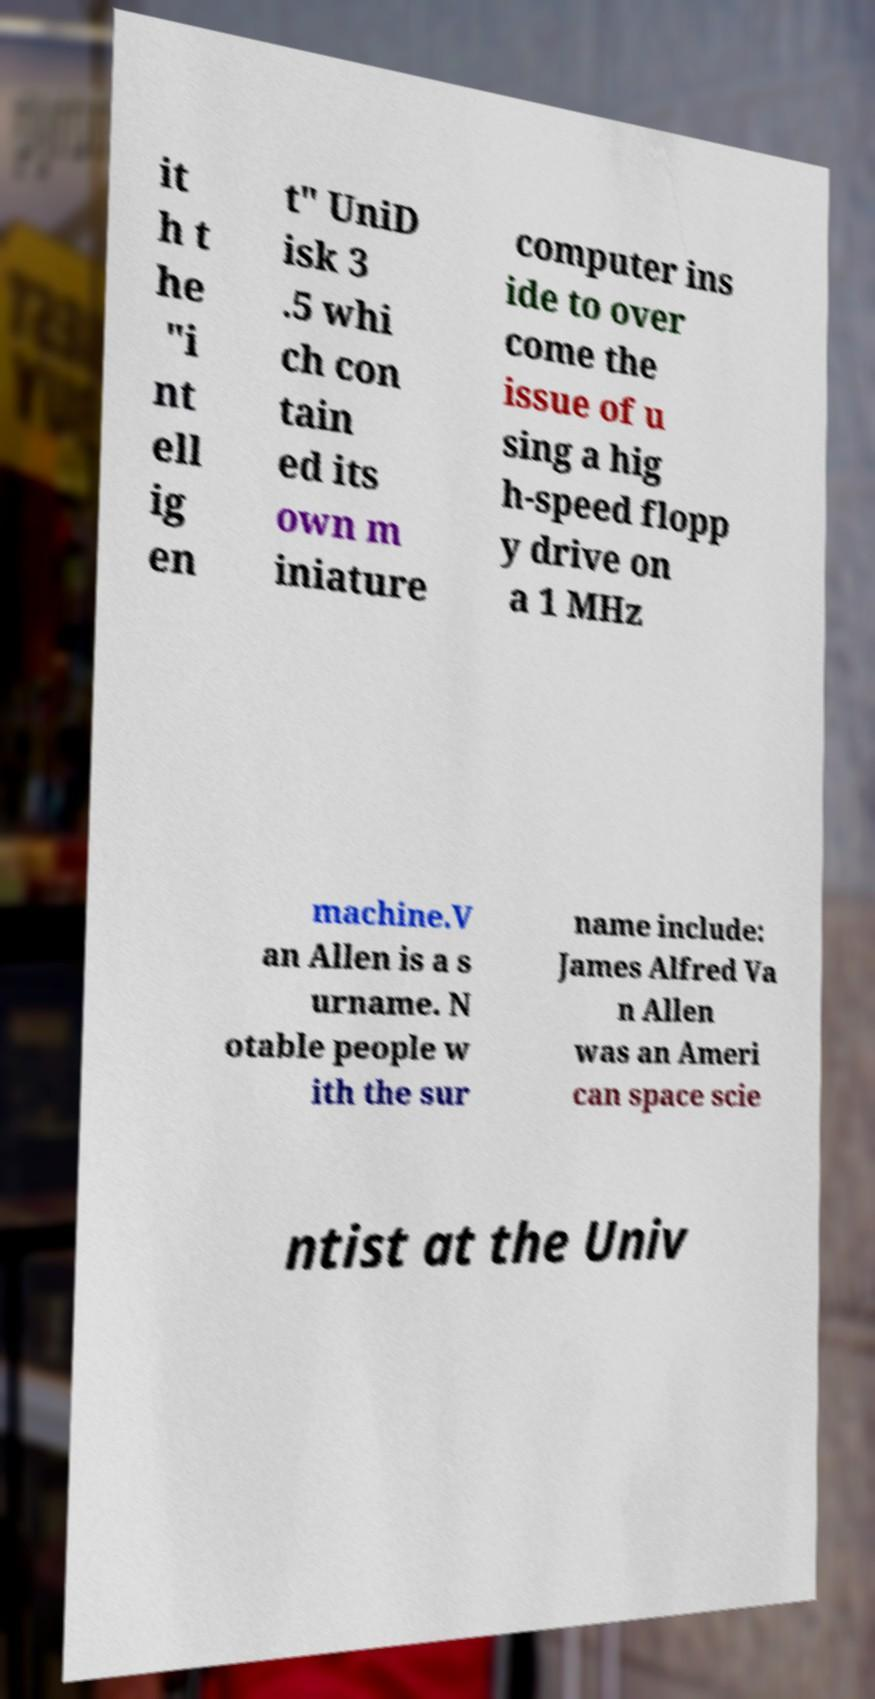For documentation purposes, I need the text within this image transcribed. Could you provide that? it h t he "i nt ell ig en t" UniD isk 3 .5 whi ch con tain ed its own m iniature computer ins ide to over come the issue of u sing a hig h-speed flopp y drive on a 1 MHz machine.V an Allen is a s urname. N otable people w ith the sur name include: James Alfred Va n Allen was an Ameri can space scie ntist at the Univ 